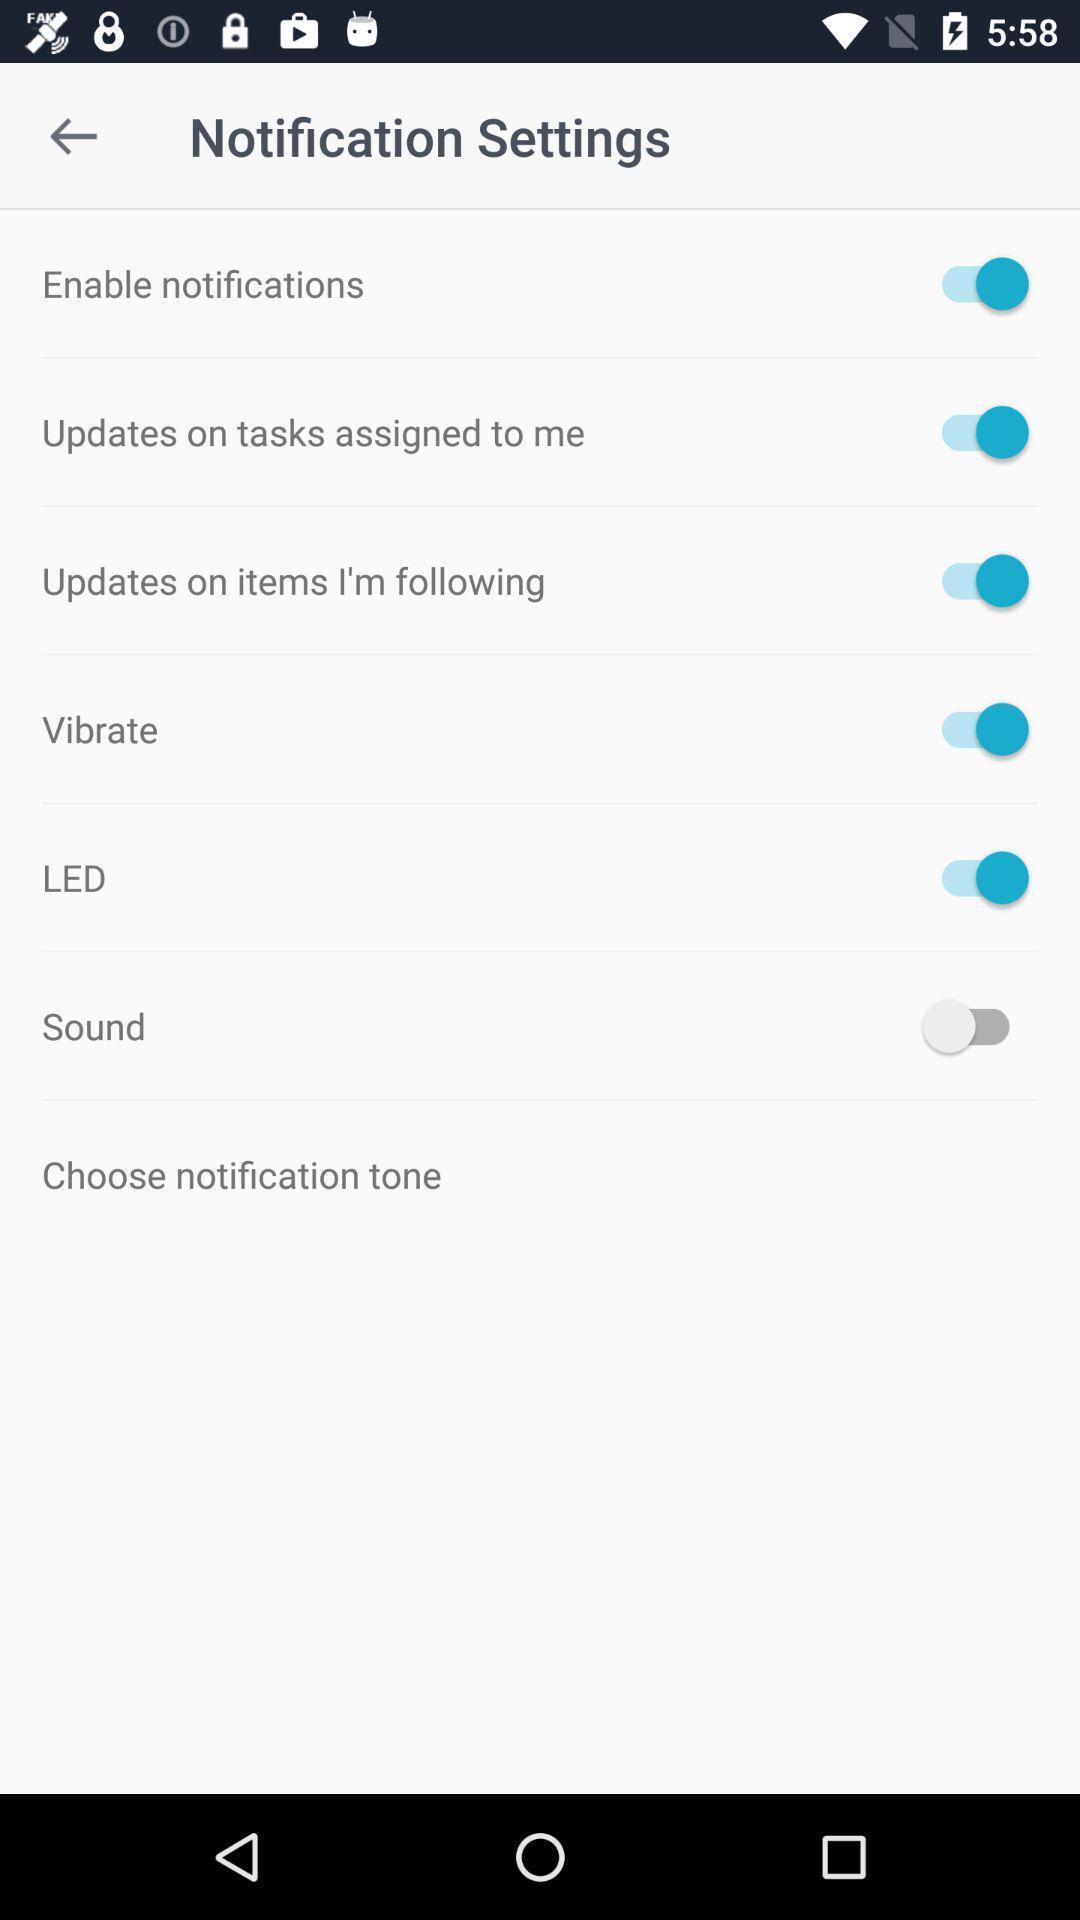Describe this image in words. Window displaying a notification settings page. 